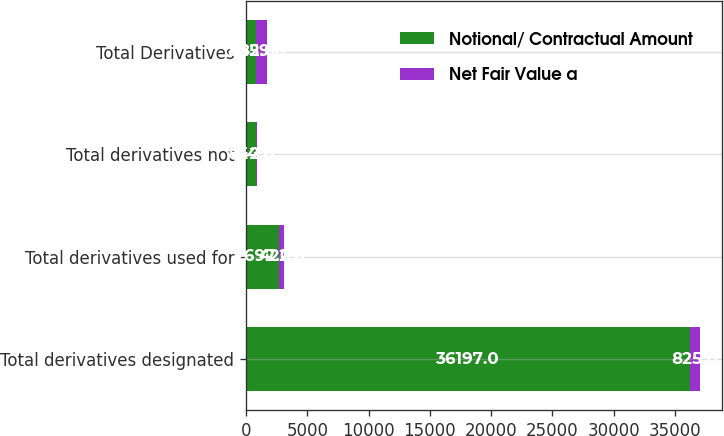Convert chart. <chart><loc_0><loc_0><loc_500><loc_500><stacked_bar_chart><ecel><fcel>Total derivatives designated<fcel>Total derivatives used for<fcel>Total derivatives not<fcel>Total Derivatives<nl><fcel>Notional/ Contractual Amount<fcel>36197<fcel>2697<fcel>842<fcel>842<nl><fcel>Net Fair Value a<fcel>825<fcel>422<fcel>34<fcel>859<nl></chart> 